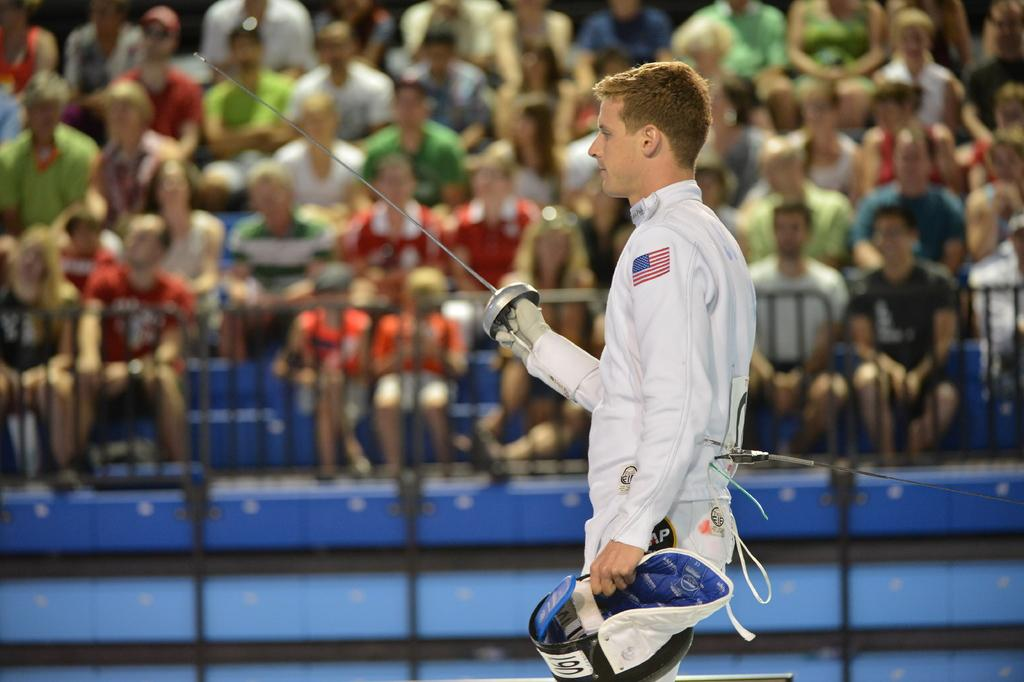What is the main subject of the image? There is a person standing at the center of the image. What is the person holding in one hand? The person is holding a fencing sword in one hand. What is the person holding in the other hand? The person is holding a cap in the other hand. Can you describe the setting of the image? There is an audience in the background of the image. Is there a water fountain visible in the image? There is no water fountain present in the image. Can you tell me how many bikes are parked near the person in the image? There are no bikes present in the image. 